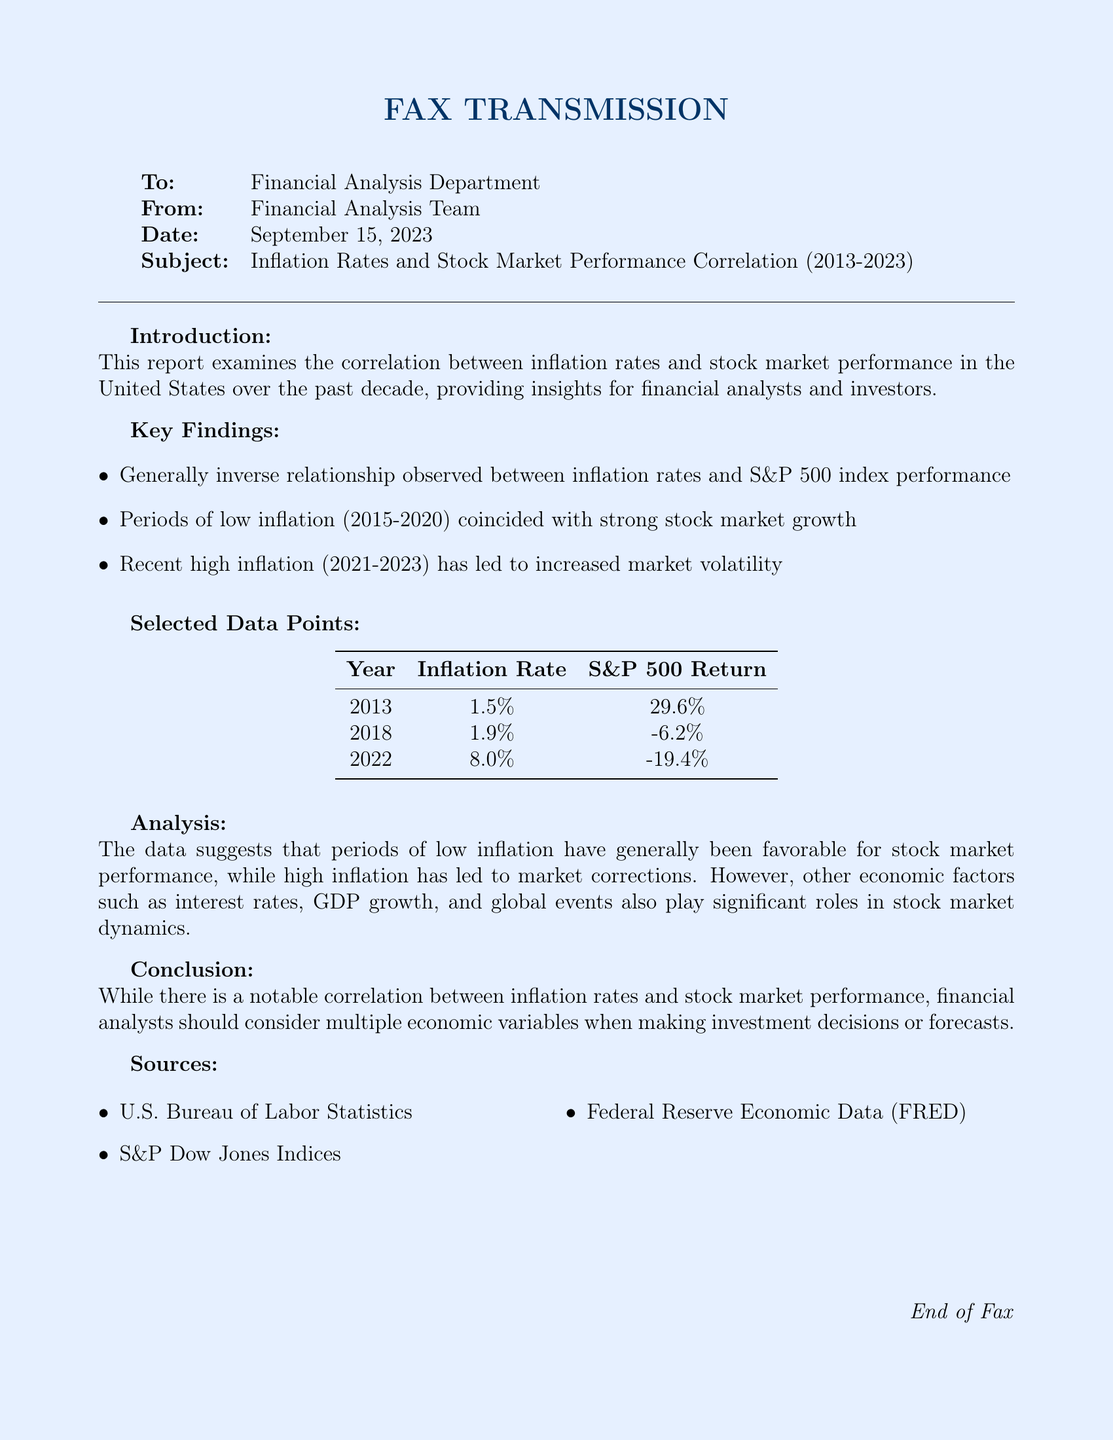What is the subject of the report? The subject of the report is indicated in the fax header under "Subject," discussing the correlation between inflation rates and stock market performance.
Answer: Inflation Rates and Stock Market Performance Correlation (2013-2023) What was the inflation rate in 2022? The inflation rate for the year 2022 is provided in the "Selected Data Points" table in the document.
Answer: 8.0% What S&P 500 return corresponds to 2018? The S&P 500 return for the year 2018 is listed in the same table as the inflation rates and is necessary for understanding the relationship between these variables.
Answer: -6.2% What period coincided with strong stock market growth? This detail is mentioned in the "Key Findings" section and relates to specific years of low inflation and strong market performance.
Answer: 2015-2020 What trend does the report indicate between inflation rates and stock market performance? The report explicitly states the relationship observed between the two variables in the "Key Findings" section.
Answer: Inverse relationship Which economic factors are noted to impact stock market dynamics? The "Analysis" section mentions other factors that significantly influence stock performance beyond inflation rates.
Answer: Interest rates, GDP growth, and global events Who are the sources cited in the document? The last section of the document lists the sources of the data used in the report, relevant for verifying the findings.
Answer: U.S. Bureau of Labor Statistics, S&P Dow Jones Indices, Federal Reserve Economic Data (FRED) What is the date of the fax transmission? The transmission date is specified in the fax header, which details the logistical information for this document.
Answer: September 15, 2023 